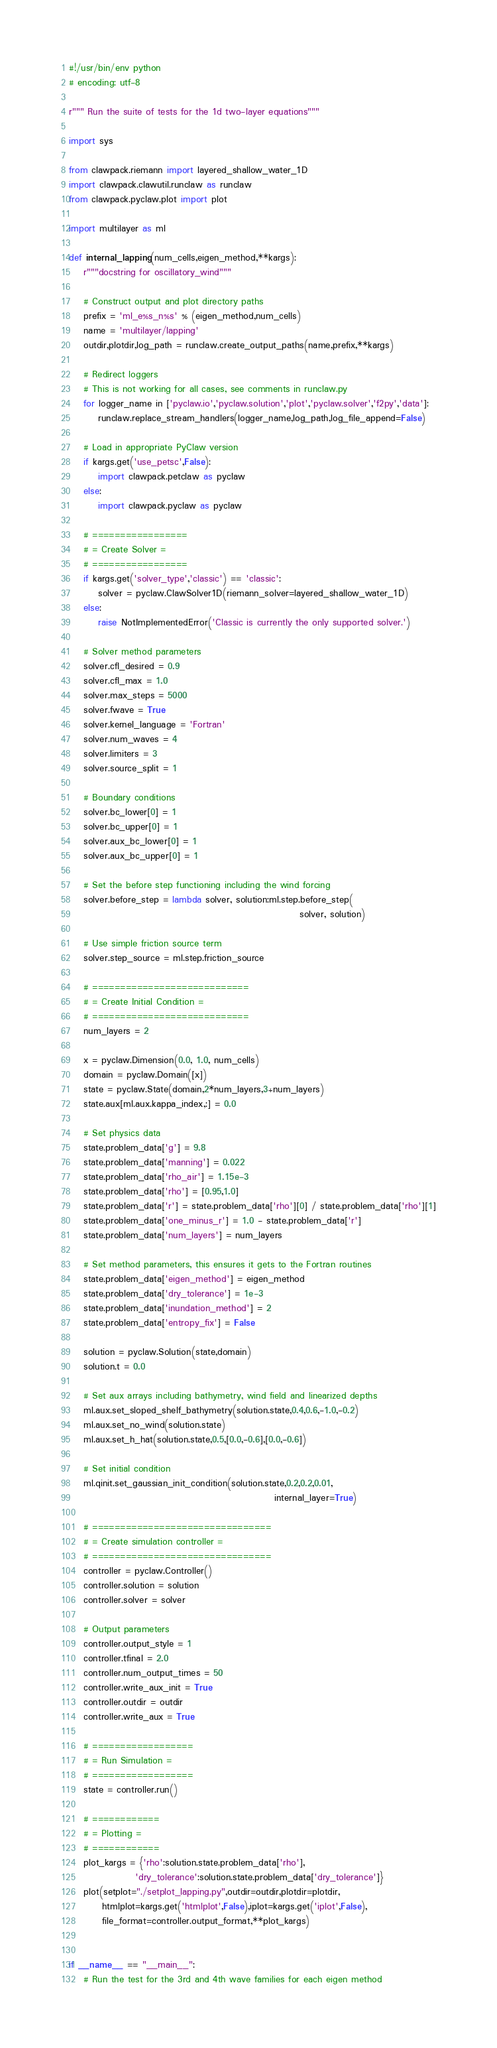Convert code to text. <code><loc_0><loc_0><loc_500><loc_500><_Python_>#!/usr/bin/env python
# encoding: utf-8

r""" Run the suite of tests for the 1d two-layer equations"""

import sys

from clawpack.riemann import layered_shallow_water_1D
import clawpack.clawutil.runclaw as runclaw
from clawpack.pyclaw.plot import plot

import multilayer as ml
        
def internal_lapping(num_cells,eigen_method,**kargs):
    r"""docstring for oscillatory_wind"""

    # Construct output and plot directory paths
    prefix = 'ml_e%s_n%s' % (eigen_method,num_cells)
    name = 'multilayer/lapping'
    outdir,plotdir,log_path = runclaw.create_output_paths(name,prefix,**kargs)
    
    # Redirect loggers
    # This is not working for all cases, see comments in runclaw.py
    for logger_name in ['pyclaw.io','pyclaw.solution','plot','pyclaw.solver','f2py','data']:
        runclaw.replace_stream_handlers(logger_name,log_path,log_file_append=False)

    # Load in appropriate PyClaw version
    if kargs.get('use_petsc',False):
        import clawpack.petclaw as pyclaw
    else:
        import clawpack.pyclaw as pyclaw

    # =================
    # = Create Solver =
    # =================
    if kargs.get('solver_type','classic') == 'classic':
        solver = pyclaw.ClawSolver1D(riemann_solver=layered_shallow_water_1D)
    else:
        raise NotImplementedError('Classic is currently the only supported solver.')
        
    # Solver method parameters
    solver.cfl_desired = 0.9
    solver.cfl_max = 1.0
    solver.max_steps = 5000
    solver.fwave = True
    solver.kernel_language = 'Fortran'
    solver.num_waves = 4
    solver.limiters = 3
    solver.source_split = 1
        
    # Boundary conditions
    solver.bc_lower[0] = 1
    solver.bc_upper[0] = 1
    solver.aux_bc_lower[0] = 1
    solver.aux_bc_upper[0] = 1

    # Set the before step functioning including the wind forcing
    solver.before_step = lambda solver, solution:ml.step.before_step(
                                                               solver, solution)
                                            
    # Use simple friction source term
    solver.step_source = ml.step.friction_source
    
    # ============================
    # = Create Initial Condition =
    # ============================
    num_layers = 2
    
    x = pyclaw.Dimension(0.0, 1.0, num_cells)
    domain = pyclaw.Domain([x])
    state = pyclaw.State(domain,2*num_layers,3+num_layers)
    state.aux[ml.aux.kappa_index,:] = 0.0

    # Set physics data
    state.problem_data['g'] = 9.8
    state.problem_data['manning'] = 0.022
    state.problem_data['rho_air'] = 1.15e-3
    state.problem_data['rho'] = [0.95,1.0]
    state.problem_data['r'] = state.problem_data['rho'][0] / state.problem_data['rho'][1]
    state.problem_data['one_minus_r'] = 1.0 - state.problem_data['r']
    state.problem_data['num_layers'] = num_layers
    
    # Set method parameters, this ensures it gets to the Fortran routines
    state.problem_data['eigen_method'] = eigen_method
    state.problem_data['dry_tolerance'] = 1e-3
    state.problem_data['inundation_method'] = 2
    state.problem_data['entropy_fix'] = False
    
    solution = pyclaw.Solution(state,domain)
    solution.t = 0.0
    
    # Set aux arrays including bathymetry, wind field and linearized depths
    ml.aux.set_sloped_shelf_bathymetry(solution.state,0.4,0.6,-1.0,-0.2)
    ml.aux.set_no_wind(solution.state)
    ml.aux.set_h_hat(solution.state,0.5,[0.0,-0.6],[0.0,-0.6])
    
    # Set initial condition
    ml.qinit.set_gaussian_init_condition(solution.state,0.2,0.2,0.01,
                                                        internal_layer=True)
    
    # ================================
    # = Create simulation controller =
    # ================================
    controller = pyclaw.Controller()
    controller.solution = solution
    controller.solver = solver
    
    # Output parameters
    controller.output_style = 1
    controller.tfinal = 2.0
    controller.num_output_times = 50
    controller.write_aux_init = True
    controller.outdir = outdir
    controller.write_aux = True
    
    # ==================
    # = Run Simulation =
    # ==================
    state = controller.run()
    
    # ============
    # = Plotting =
    # ============
    plot_kargs = {'rho':solution.state.problem_data['rho'],
                  'dry_tolerance':solution.state.problem_data['dry_tolerance']}
    plot(setplot="./setplot_lapping.py",outdir=outdir,plotdir=plotdir,
         htmlplot=kargs.get('htmlplot',False),iplot=kargs.get('iplot',False),
         file_format=controller.output_format,**plot_kargs)


if __name__ == "__main__":
    # Run the test for the 3rd and 4th wave families for each eigen method</code> 